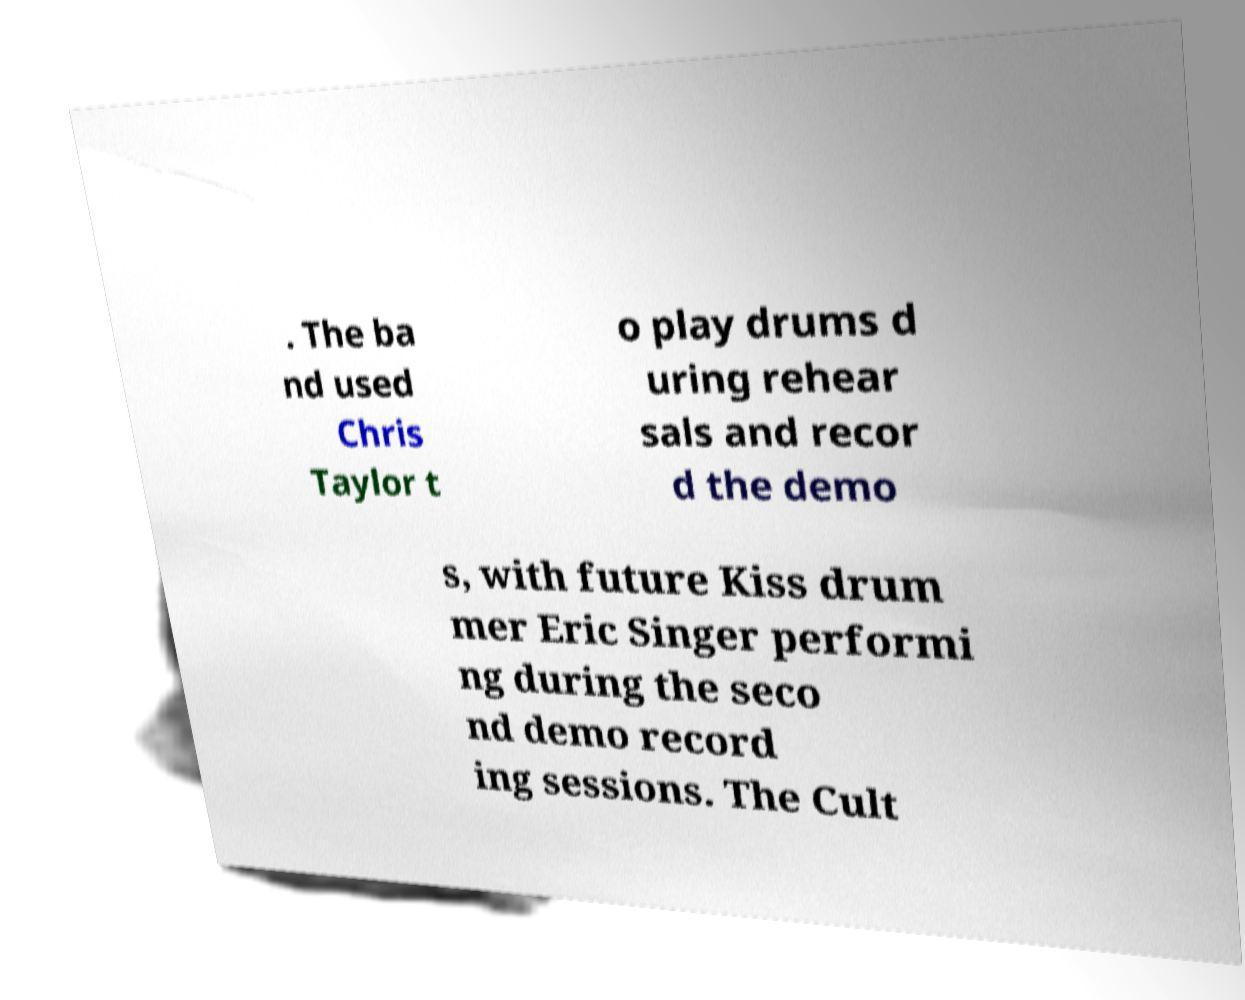There's text embedded in this image that I need extracted. Can you transcribe it verbatim? . The ba nd used Chris Taylor t o play drums d uring rehear sals and recor d the demo s, with future Kiss drum mer Eric Singer performi ng during the seco nd demo record ing sessions. The Cult 